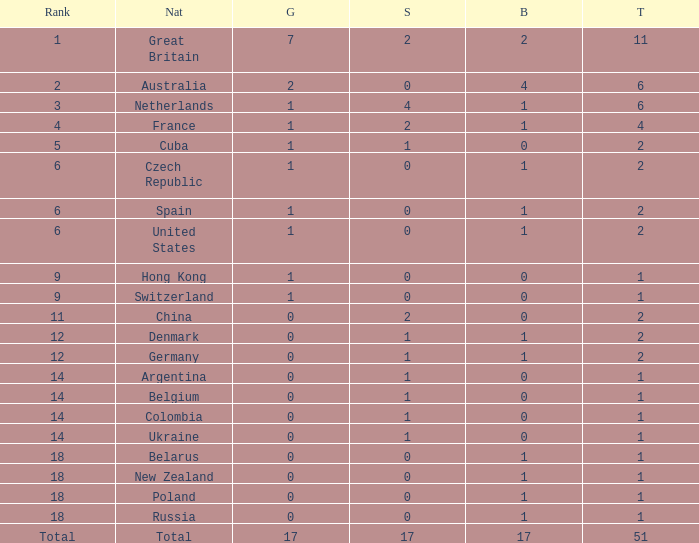Tell me the rank for bronze less than 17 and gold less than 1 11.0. 